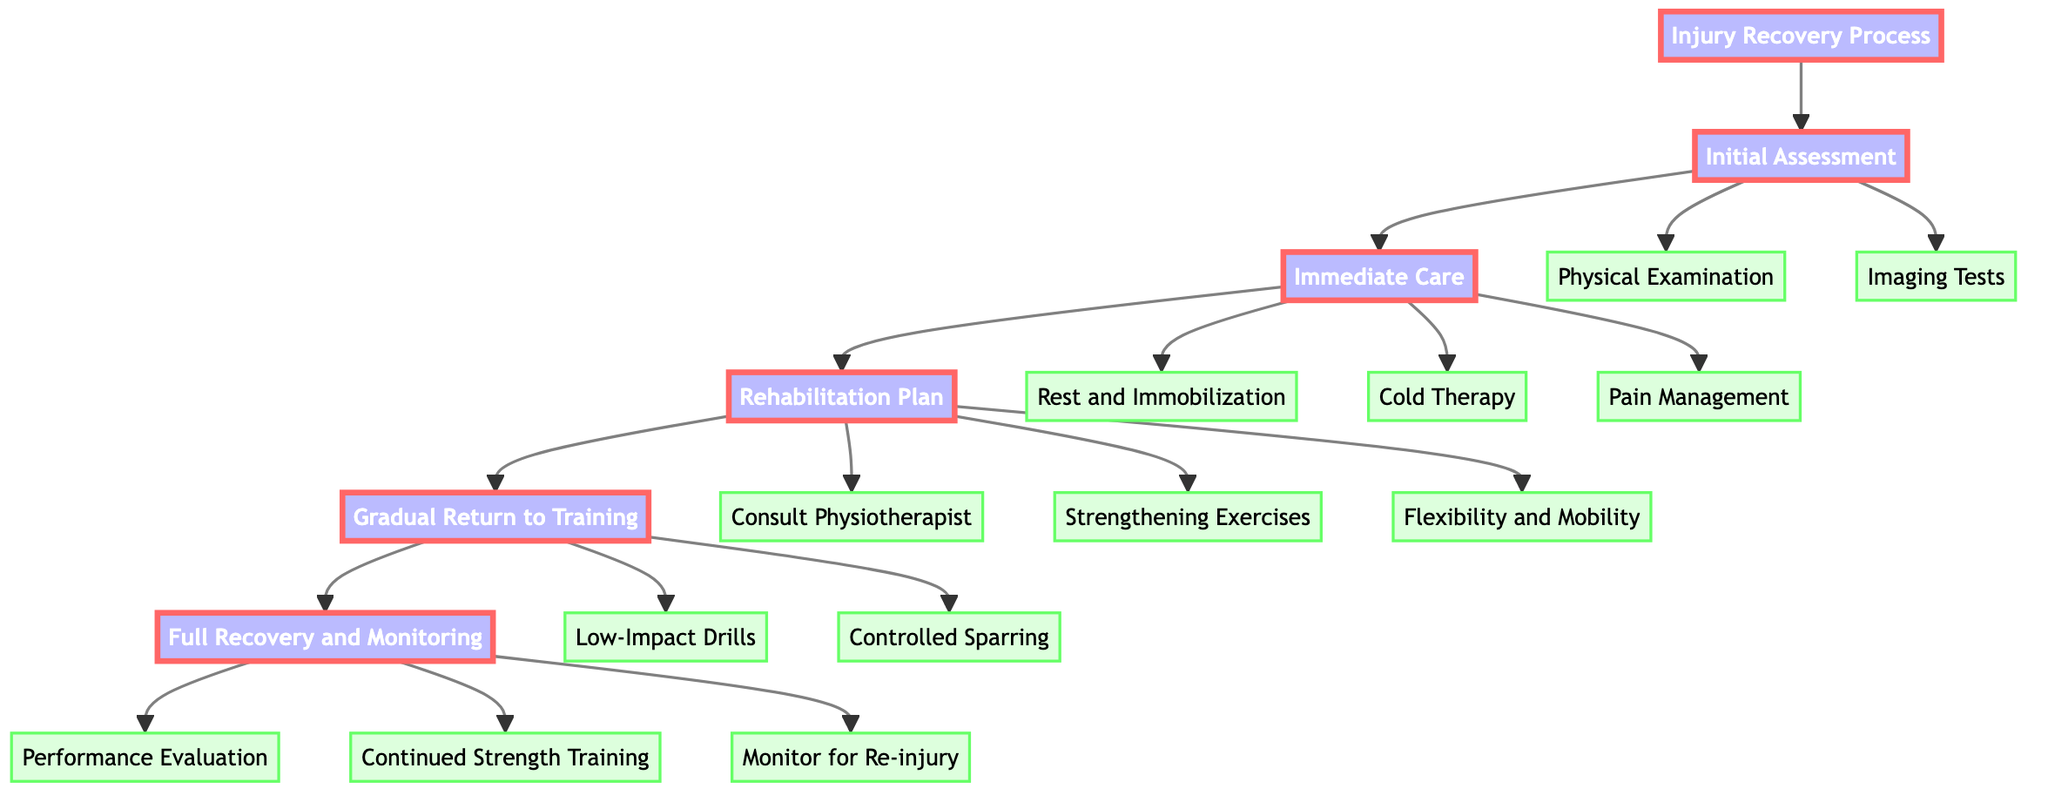What is the first phase in the injury recovery process? The first phase is represented as the starting node connected to the "Injury Recovery Process" and is labeled "Initial Assessment."
Answer: Initial Assessment How many key steps are associated with 'Immediate Care'? The "Immediate Care" phase has three key steps connected to it: "Rest and Immobilization," "Cold Therapy," and "Pain Management." Therefore, there are a total of three key steps in this phase.
Answer: 3 What follows after 'Rehabilitation Plan' in the flowchart? The flowchart shows an arrow pointing from "Rehabilitation Plan" to "Gradual Return to Training," indicating that "Gradual Return to Training" is the subsequent phase following "Rehabilitation Plan."
Answer: Gradual Return to Training Which phase includes 'Performance Evaluation'? The node labeled "Performance Evaluation" is connected to the "Full Recovery and Monitoring" phase, indicating that this phase includes the evaluation of performance.
Answer: Full Recovery and Monitoring What is the total number of phases in the injury recovery process? There are a total of six phases shown in the diagram: "Initial Assessment," "Immediate Care," "Rehabilitation Plan," "Gradual Return to Training," "Full Recovery and Monitoring." Thus, six phases encompass the entire injury recovery process.
Answer: 6 Which key step is involved in creating a personalized rehabilitation plan? The step responsible for creating a personalized rehabilitation plan is "Consult Physiotherapist," which is a part of the "Rehabilitation Plan" phase.
Answer: Consult Physiotherapist What types of therapy are included in 'Immediate Care'? The "Immediate Care" phase includes three types of therapy: "Rest and Immobilization," "Cold Therapy," and "Pain Management." Therefore, these are the therapies involved during this step.
Answer: Rest and Immobilization, Cold Therapy, Pain Management What action should be taken during the 'Gradual Return to Training' step? During the "Gradual Return to Training," the recommended actions are "Low-Impact Drills" and "Controlled Sparring," addressing a slow and careful return to wrestling practice.
Answer: Low-Impact Drills, Controlled Sparring 